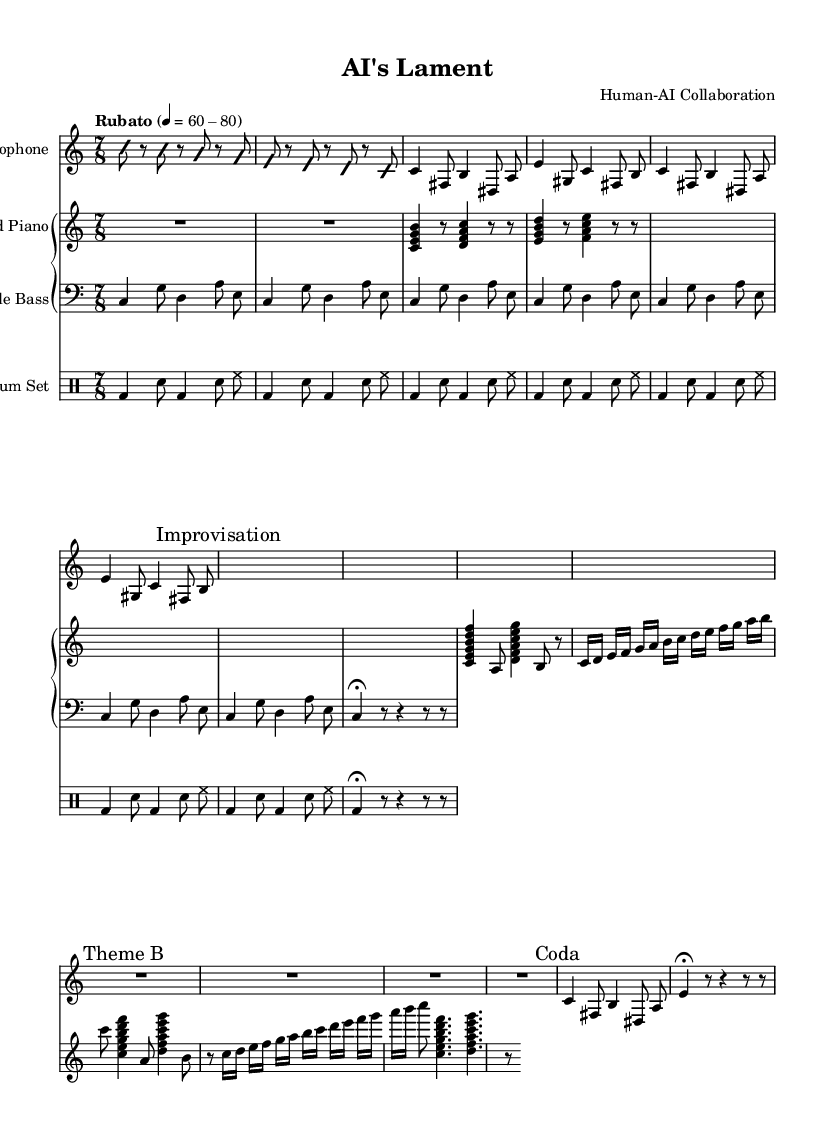what is the time signature of this piece? The time signature is displayed at the beginning of the score, indicating the rhythmic structure. Here, it shows 7/8, which signifies that there are 7 beats in each measure, with the eighth note receiving one beat.
Answer: 7/8 what is the tempo marking for this composition? The tempo marking is noted at the beginning of the score as "Rubato," followed by tempo indications of 60-80. This means the piece should be played freely with slight variations in speed, generally within the beats per minute specified.
Answer: Rubato 60-80 how many times is Theme A repeated in the piece? The written music for Theme A indicates a "repeat" instruction, showing that it is played two times in succession. This can be seen in the use of the repeat signs before and after the passage labeled Theme A.
Answer: 2 what type of piano is used in this composition? The score indicates the piano section as "Prepared Piano," which refers to a piano that has had its sound altered by placing objects on or between its strings, creating a unique tonal quality.
Answer: Prepared Piano how is improvisation indicated in this score? Improvisation is marked clearly within the music by the inscription "Improvisation," followed by a section with no notated pitches, indicating freedom of expression for the player. The absence of specific notes points to this style.
Answer: Improvisation which instrument plays the Coda section? The Coda section is notated in the alto saxophone part, indicating that this is where the piece concludes, connecting back to themes and motifs established earlier, specifically with repeating patterns.
Answer: Alto Saxophone what are the primary rhythmic elements in the drum part? The drum part is structured around a basic repeating pattern that includes bass drum, snare drum, and hi-hat. The rhythm follows a recurring sequence that reflects the piece's time signature and jazz style.
Answer: Bass drum, snare, hi-hat 